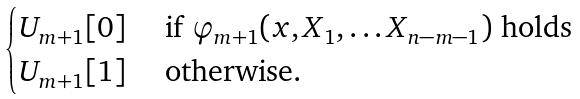Convert formula to latex. <formula><loc_0><loc_0><loc_500><loc_500>\begin{cases} U _ { m + 1 } [ 0 ] & \text { if } \varphi _ { m + 1 } ( x , X _ { 1 } , \dots X _ { n - m - 1 } ) \text { holds} \\ U _ { m + 1 } [ 1 ] & \text { otherwise.} \end{cases}</formula> 